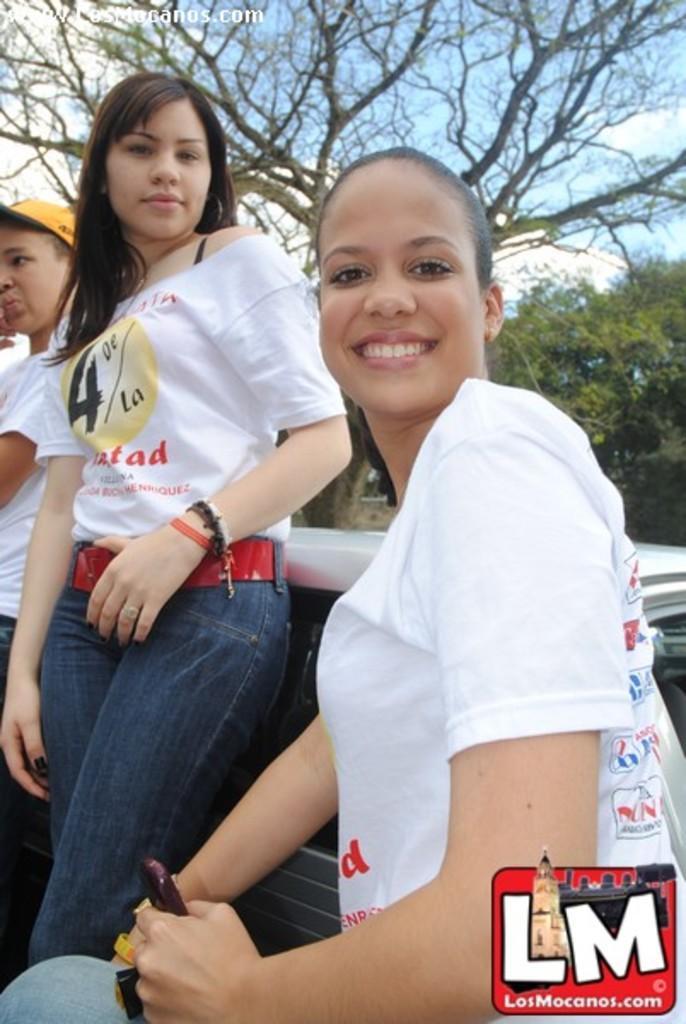Can you describe this image briefly? In this image in front there is a person wearing a smile on her smile. Beside her there are two other people standing. Behind them there is a table. In the background of the image there are trees and sky. There is some text at the top of the image. There is a watermark at the bottom of the image. 